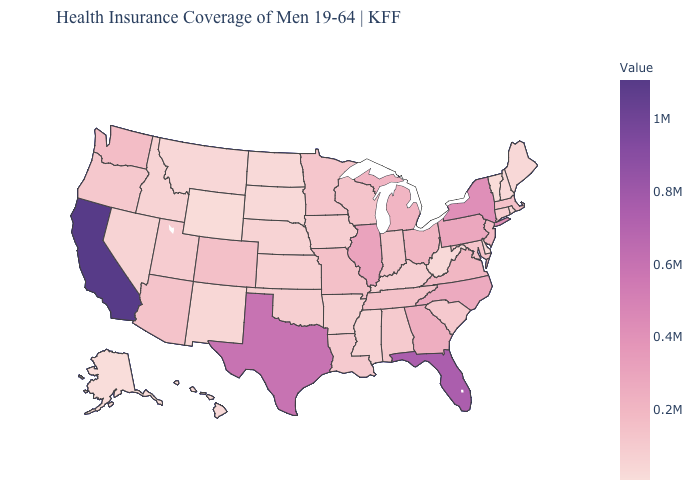Among the states that border Michigan , which have the lowest value?
Be succinct. Indiana. Does the map have missing data?
Keep it brief. No. Does the map have missing data?
Answer briefly. No. Does West Virginia have the highest value in the USA?
Be succinct. No. Which states have the highest value in the USA?
Concise answer only. California. Which states have the lowest value in the MidWest?
Concise answer only. North Dakota. 